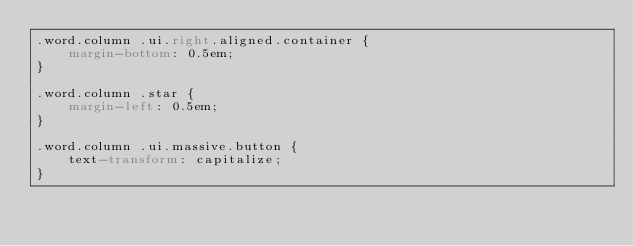<code> <loc_0><loc_0><loc_500><loc_500><_CSS_>.word.column .ui.right.aligned.container {
    margin-bottom: 0.5em;
}

.word.column .star {
    margin-left: 0.5em;
}

.word.column .ui.massive.button {
    text-transform: capitalize;
}
</code> 